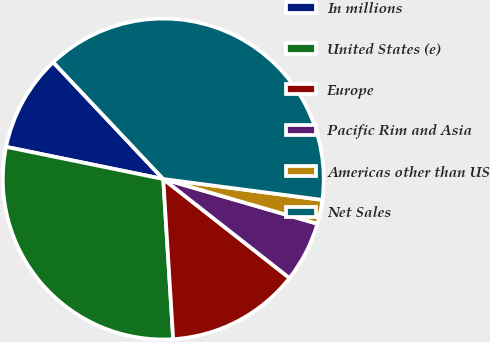<chart> <loc_0><loc_0><loc_500><loc_500><pie_chart><fcel>In millions<fcel>United States (e)<fcel>Europe<fcel>Pacific Rim and Asia<fcel>Americas other than US<fcel>Net Sales<nl><fcel>9.76%<fcel>29.2%<fcel>13.43%<fcel>6.09%<fcel>2.42%<fcel>39.11%<nl></chart> 